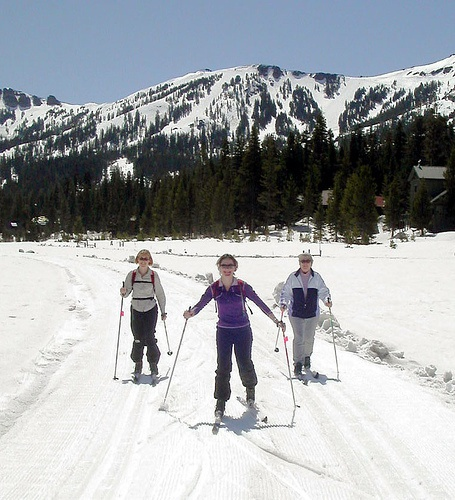Describe the objects in this image and their specific colors. I can see people in darkgray, navy, gray, purple, and black tones, people in darkgray, black, gray, and white tones, people in darkgray, gray, black, and navy tones, skis in darkgray, lightgray, and gray tones, and skis in darkgray and gray tones in this image. 